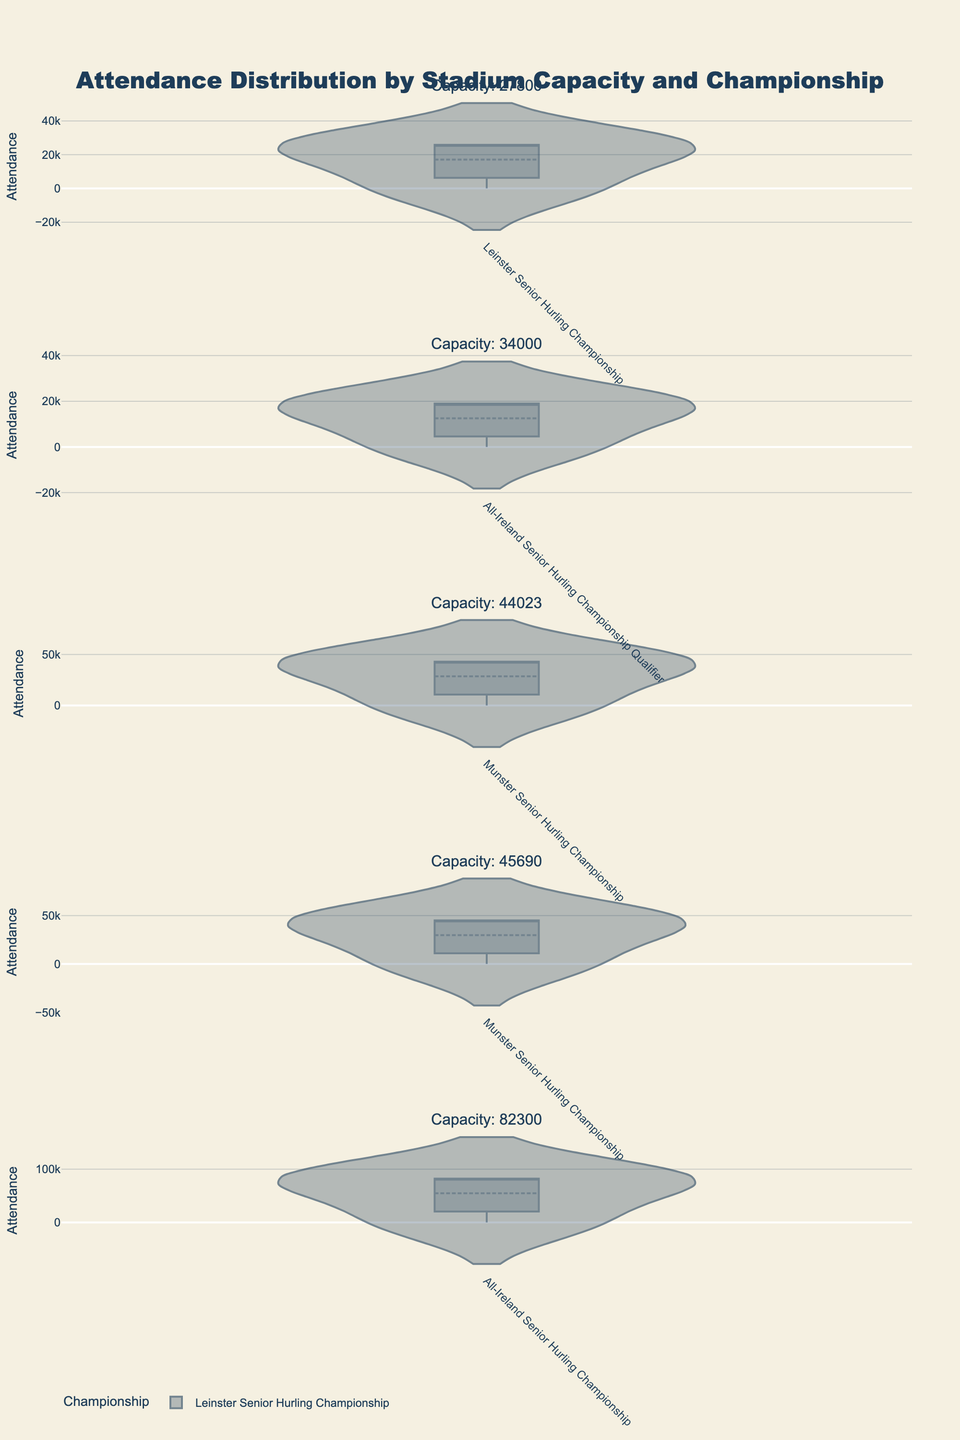What's the title of the figure? The title is displayed at the top of the plot in the largest text size. It describes the main focus of the plot.
Answer: Attendance Distribution by Stadium Capacity and Championship How many subplots are there in the figure? The figure has one subplot for each unique stadium capacity, and there are four different capacities listed in the data.
Answer: 4 What is the y-axis title in the plots? The y-axis title indicates what the numerical values represent, which in this case is 'Attendance'.
Answer: Attendance Which stadium has the highest capacity? The subplot titles indicate the stadium capacities. By comparing them, Croke Park has the highest capacity.
Answer: Croke Park Which stadiums had zero attendance in 2020? The violin plots for different years within the same subplot show zero attendance events. All stadiums in the data had zero attendance in 2020.
Answer: All stadiums Which championship appears in stadiums with different capacities? By comparing the unique championships within each subplot, the "All-Ireland Senior Hurling Championship" appears in both Croke Park and Pearse Stadium.
Answer: All-Ireland Senior Hurling Championship Compare the average attendance for the All-Ireland Senior Hurling Championship between 2018 and 2019 in Croke Park. We need to consider the values in the plot for "All-Ireland Senior Hurling Championship" at Croke Park, calculate the average attendance for each year, and then compare them. For both years, attendance is around 82,000, so they are roughly equal.
Answer: Roughly equal Which championship has the lowest attendance figures in Pearse Stadium? By looking at the violin plots for Pearse Stadium, "All-Ireland Senior Hurling Championship Qualifier" has lower attendance values compared to other championships.
Answer: All-Ireland Senior Hurling Championship Qualifier 